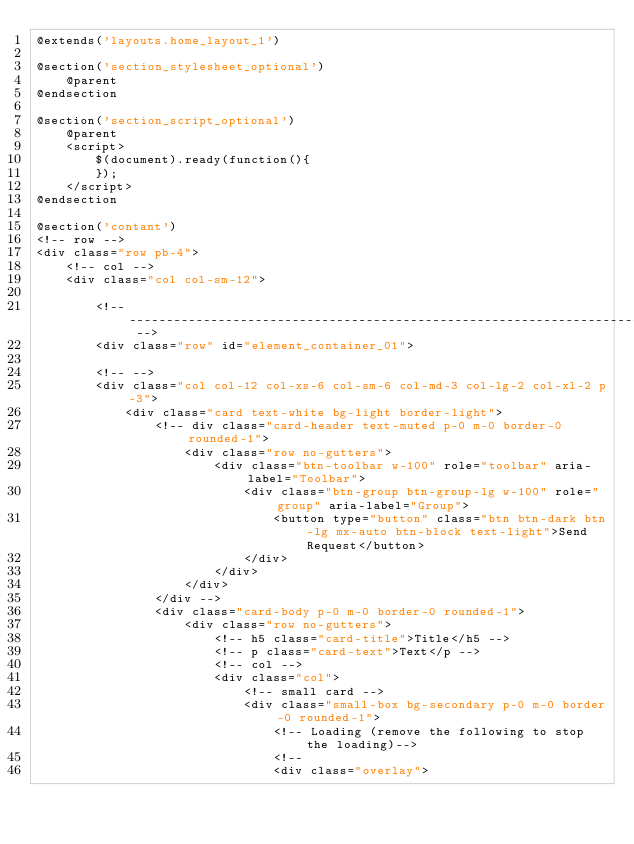Convert code to text. <code><loc_0><loc_0><loc_500><loc_500><_PHP_>@extends('layouts.home_layout_1')

@section('section_stylesheet_optional')
    @parent
@endsection

@section('section_script_optional')
    @parent
    <script>
        $(document).ready(function(){
        }); 
    </script>
@endsection

@section('contant')
<!-- row -->
<div class="row pb-4">
    <!-- col -->
    <div class="col col-sm-12">

        <!-- ---------------------------------------------------------------------------- -->
        <div class="row" id="element_container_01">
            
        <!-- -->
        <div class="col col-12 col-xs-6 col-sm-6 col-md-3 col-lg-2 col-xl-2 p-3">
            <div class="card text-white bg-light border-light">
                <!-- div class="card-header text-muted p-0 m-0 border-0 rounded-1">
                    <div class="row no-gutters">
                        <div class="btn-toolbar w-100" role="toolbar" aria-label="Toolbar">
                            <div class="btn-group btn-group-lg w-100" role="group" aria-label="Group">
                                <button type="button" class="btn btn-dark btn-lg mx-auto btn-block text-light">Send Request</button>
                            </div>
                        </div>
                    </div>
                </div -->
                <div class="card-body p-0 m-0 border-0 rounded-1">
                    <div class="row no-gutters">
                        <!-- h5 class="card-title">Title</h5 -->
                        <!-- p class="card-text">Text</p -->
                        <!-- col -->
                        <div class="col">
                            <!-- small card -->
                            <div class="small-box bg-secondary p-0 m-0 border-0 rounded-1">
                                <!-- Loading (remove the following to stop the loading)-->
                                <!--
                                <div class="overlay"></code> 